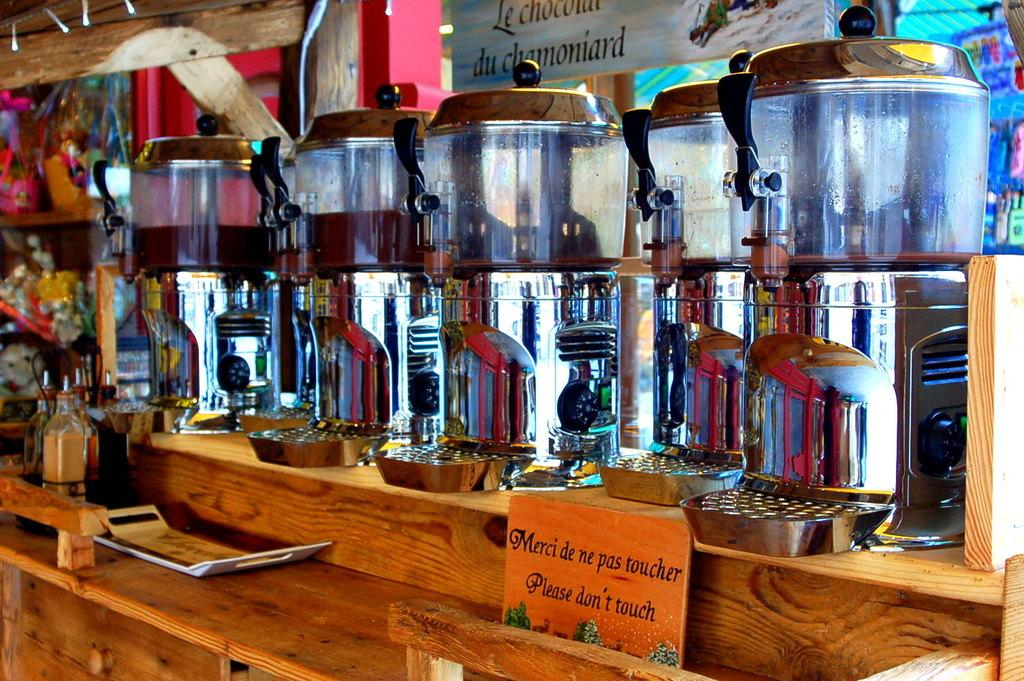<image>
Present a compact description of the photo's key features. a drink bar that has a sign that says 'merci de ne pas toucher please don't touch' on it 